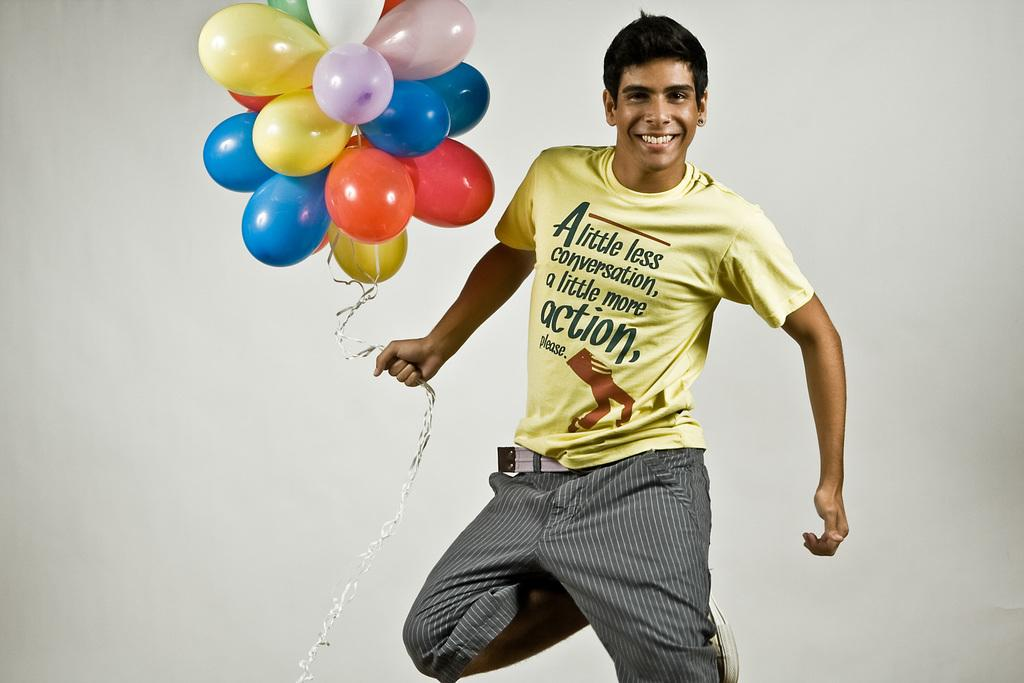What is the main subject of the image? The main subject of the image is a man. What type of clothing is the man wearing on his upper body? The man is wearing a t-shirt. What type of clothing is the man wearing on his lower body? The man is wearing trousers. What type of footwear is the man wearing? The man is wearing sneakers. What is the man holding in the image? The man is holding balloons. What type of art can be seen on the walls of the house in the image? There is no house or art present in the image; it features a man holding balloons. What type of destruction is occurring in the image? There is no destruction present in the image; it features a man holding balloons. 